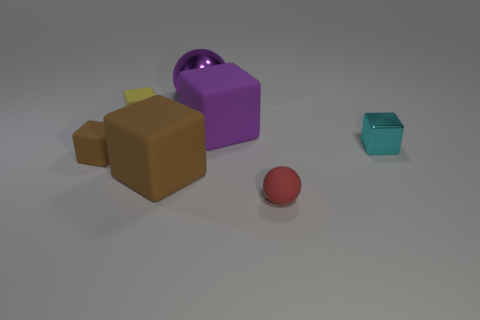What size is the object that is behind the big purple rubber cube and in front of the purple metallic sphere?
Provide a succinct answer. Small. Is the number of tiny yellow objects to the right of the big shiny object less than the number of shiny cylinders?
Give a very brief answer. No. The small red object that is the same material as the tiny yellow cube is what shape?
Offer a terse response. Sphere. Does the object that is right of the small ball have the same shape as the brown matte object that is to the right of the small yellow rubber block?
Give a very brief answer. Yes. Are there fewer big purple matte things that are right of the tiny cyan shiny thing than red matte things that are behind the small red ball?
Your answer should be very brief. No. What shape is the big rubber thing that is the same color as the shiny sphere?
Provide a succinct answer. Cube. How many blocks are the same size as the red rubber thing?
Your answer should be very brief. 3. Do the tiny block on the right side of the small red matte thing and the small brown object have the same material?
Your response must be concise. No. Is there a yellow matte cylinder?
Your answer should be very brief. No. What size is the cyan thing that is made of the same material as the big sphere?
Your answer should be compact. Small. 